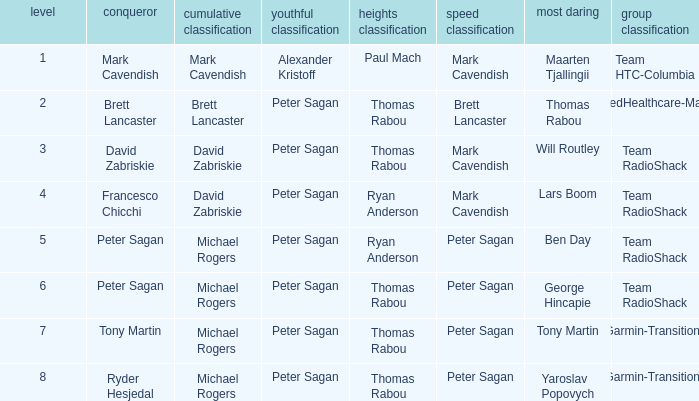When ryan anderson claimed the mountains classification, and michael rogers secured the general classification, who achieved the sprint classification? Peter Sagan. 